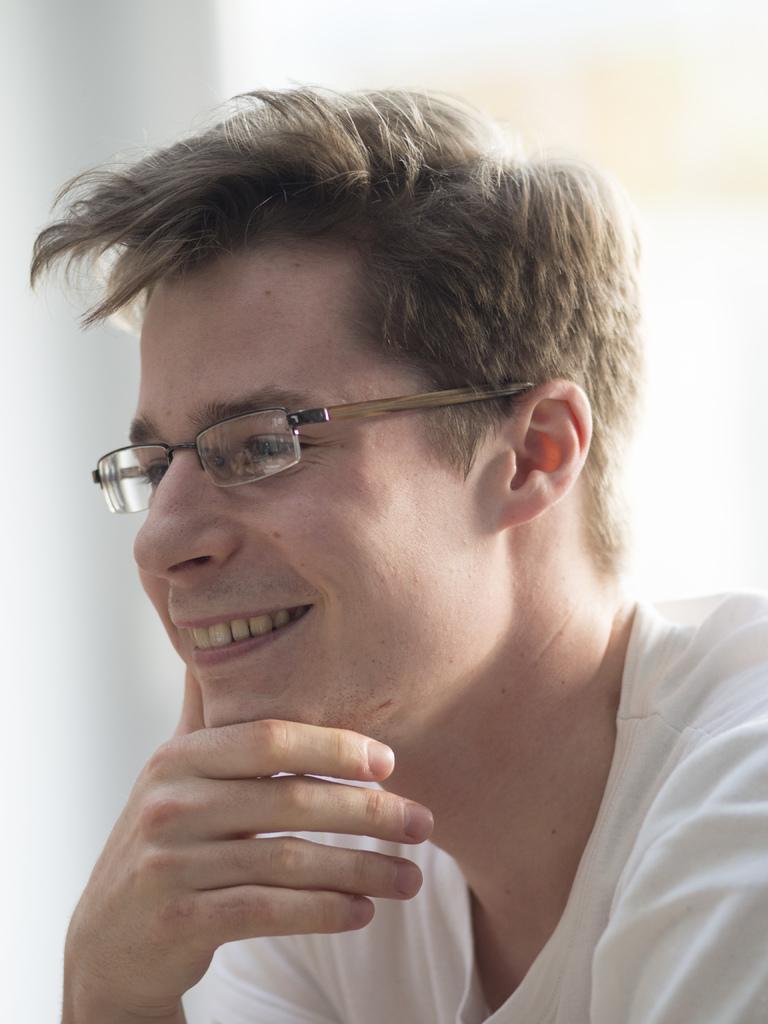How would you summarize this image in a sentence or two? In this picture we can see a person wearing a spectacle and smiling. 